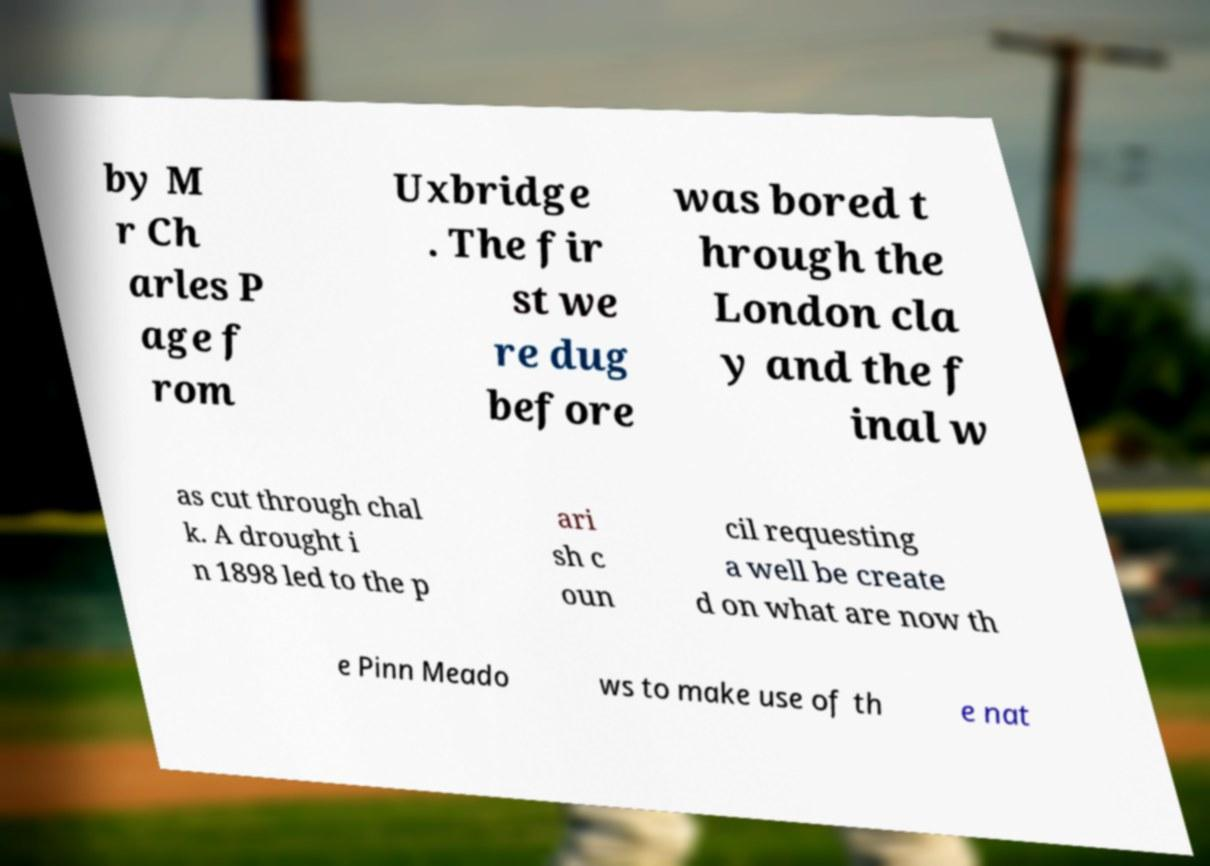There's text embedded in this image that I need extracted. Can you transcribe it verbatim? by M r Ch arles P age f rom Uxbridge . The fir st we re dug before was bored t hrough the London cla y and the f inal w as cut through chal k. A drought i n 1898 led to the p ari sh c oun cil requesting a well be create d on what are now th e Pinn Meado ws to make use of th e nat 